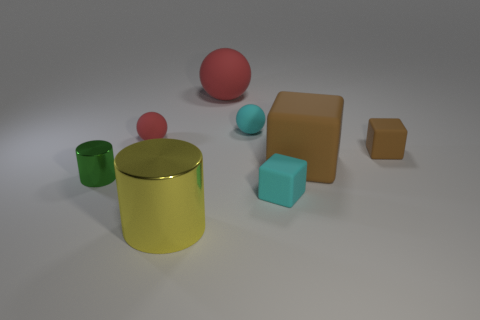How many red balls must be subtracted to get 1 red balls? 1 Add 2 big spheres. How many objects exist? 10 Subtract all cubes. How many objects are left? 5 Subtract all red metallic cylinders. Subtract all cyan rubber cubes. How many objects are left? 7 Add 5 red things. How many red things are left? 7 Add 1 red balls. How many red balls exist? 3 Subtract 0 purple cylinders. How many objects are left? 8 